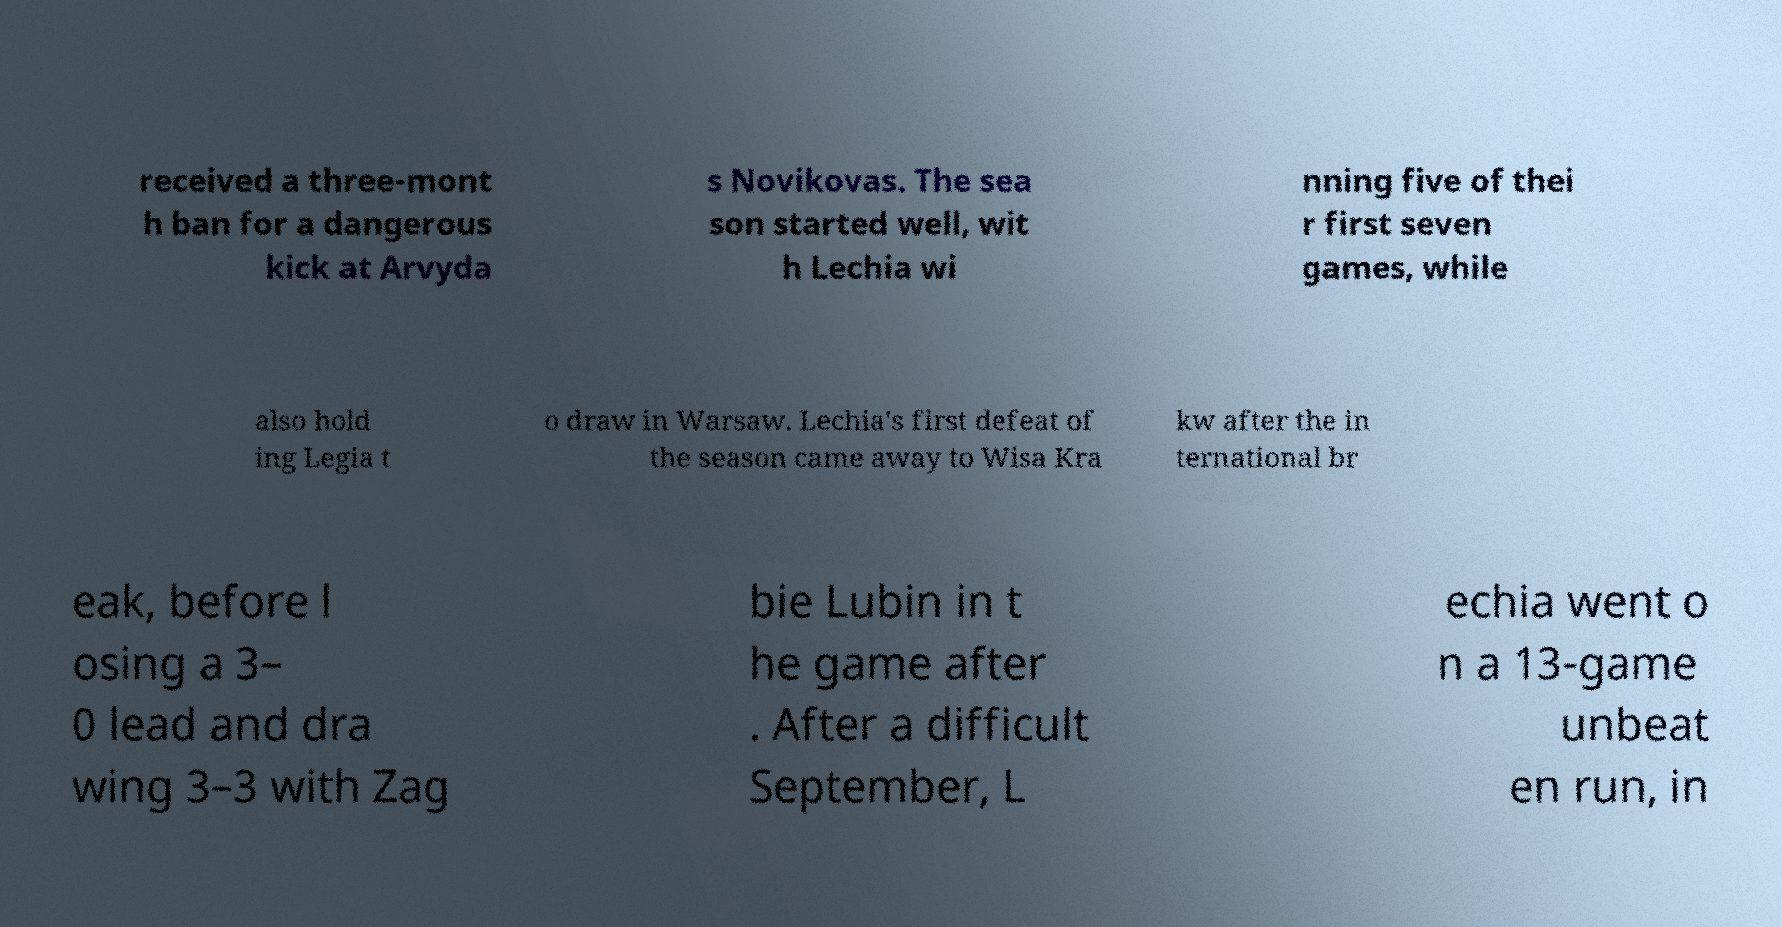Can you accurately transcribe the text from the provided image for me? received a three-mont h ban for a dangerous kick at Arvyda s Novikovas. The sea son started well, wit h Lechia wi nning five of thei r first seven games, while also hold ing Legia t o draw in Warsaw. Lechia's first defeat of the season came away to Wisa Kra kw after the in ternational br eak, before l osing a 3– 0 lead and dra wing 3–3 with Zag bie Lubin in t he game after . After a difficult September, L echia went o n a 13-game unbeat en run, in 